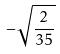<formula> <loc_0><loc_0><loc_500><loc_500>- \sqrt { \frac { 2 } { 3 5 } }</formula> 